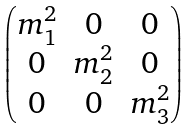<formula> <loc_0><loc_0><loc_500><loc_500>\begin{pmatrix} m _ { 1 } ^ { 2 } & 0 & 0 \\ 0 & m _ { 2 } ^ { 2 } & 0 \\ 0 & 0 & m _ { 3 } ^ { 2 } \\ \end{pmatrix}</formula> 